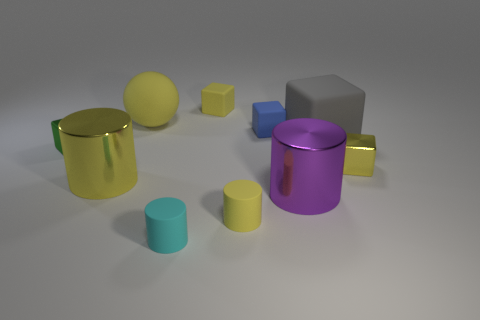Subtract all green cubes. How many cubes are left? 4 Subtract 2 blocks. How many blocks are left? 3 Subtract all blue blocks. How many blocks are left? 4 Subtract all green cubes. Subtract all green balls. How many cubes are left? 4 Subtract all cylinders. How many objects are left? 6 Subtract all big spheres. Subtract all purple metallic objects. How many objects are left? 8 Add 9 yellow balls. How many yellow balls are left? 10 Add 8 small purple metal things. How many small purple metal things exist? 8 Subtract 1 blue blocks. How many objects are left? 9 